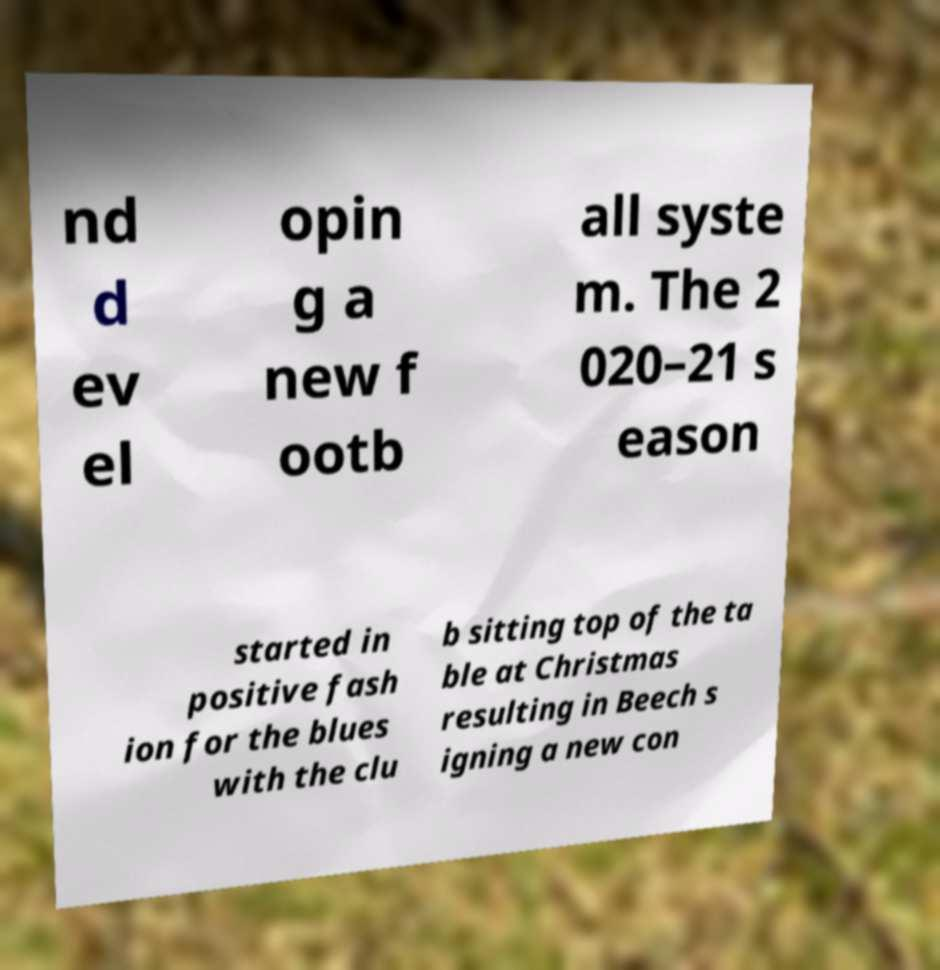Could you assist in decoding the text presented in this image and type it out clearly? nd d ev el opin g a new f ootb all syste m. The 2 020–21 s eason started in positive fash ion for the blues with the clu b sitting top of the ta ble at Christmas resulting in Beech s igning a new con 